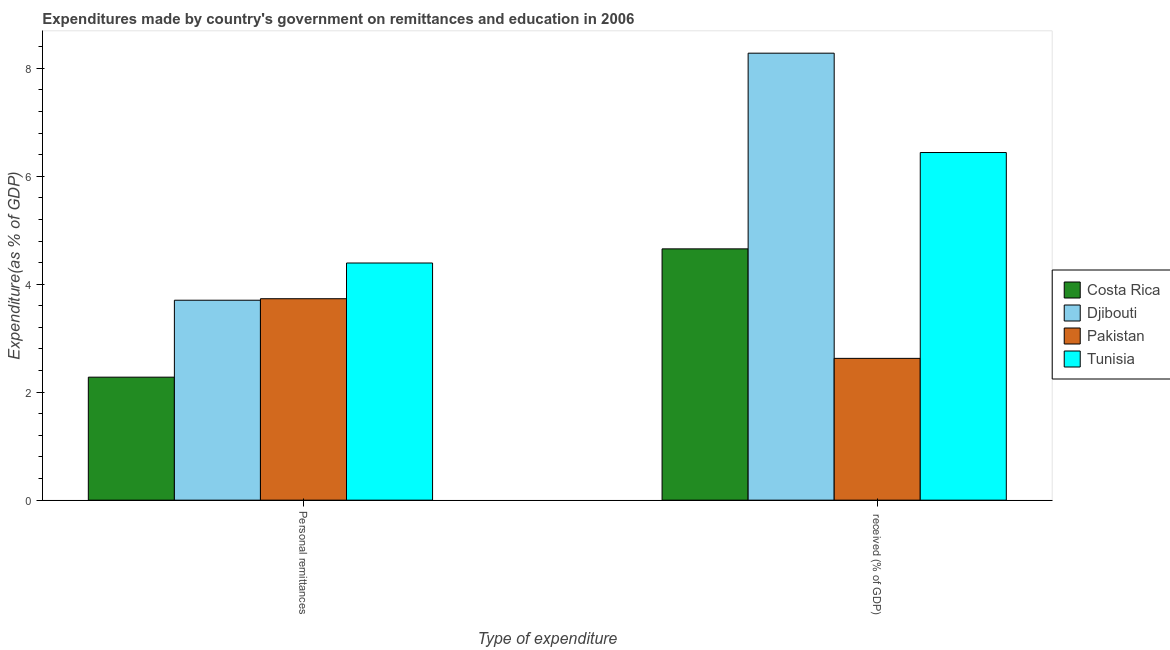How many different coloured bars are there?
Give a very brief answer. 4. What is the label of the 2nd group of bars from the left?
Your answer should be compact.  received (% of GDP). What is the expenditure in education in Costa Rica?
Provide a succinct answer. 4.65. Across all countries, what is the maximum expenditure in personal remittances?
Your answer should be compact. 4.39. Across all countries, what is the minimum expenditure in personal remittances?
Make the answer very short. 2.28. In which country was the expenditure in personal remittances maximum?
Provide a short and direct response. Tunisia. What is the total expenditure in education in the graph?
Provide a succinct answer. 22. What is the difference between the expenditure in personal remittances in Tunisia and that in Djibouti?
Offer a very short reply. 0.69. What is the difference between the expenditure in personal remittances in Djibouti and the expenditure in education in Costa Rica?
Ensure brevity in your answer.  -0.95. What is the average expenditure in personal remittances per country?
Your answer should be compact. 3.53. What is the difference between the expenditure in personal remittances and expenditure in education in Tunisia?
Keep it short and to the point. -2.05. In how many countries, is the expenditure in personal remittances greater than 2.4 %?
Keep it short and to the point. 3. What is the ratio of the expenditure in education in Tunisia to that in Djibouti?
Your response must be concise. 0.78. In how many countries, is the expenditure in personal remittances greater than the average expenditure in personal remittances taken over all countries?
Provide a succinct answer. 3. What does the 2nd bar from the left in  received (% of GDP) represents?
Provide a succinct answer. Djibouti. What does the 4th bar from the right in Personal remittances represents?
Offer a terse response. Costa Rica. Are all the bars in the graph horizontal?
Offer a terse response. No. How many countries are there in the graph?
Make the answer very short. 4. What is the difference between two consecutive major ticks on the Y-axis?
Your answer should be compact. 2. Are the values on the major ticks of Y-axis written in scientific E-notation?
Make the answer very short. No. Does the graph contain grids?
Make the answer very short. No. How are the legend labels stacked?
Give a very brief answer. Vertical. What is the title of the graph?
Ensure brevity in your answer.  Expenditures made by country's government on remittances and education in 2006. What is the label or title of the X-axis?
Your answer should be very brief. Type of expenditure. What is the label or title of the Y-axis?
Provide a short and direct response. Expenditure(as % of GDP). What is the Expenditure(as % of GDP) of Costa Rica in Personal remittances?
Provide a short and direct response. 2.28. What is the Expenditure(as % of GDP) in Djibouti in Personal remittances?
Provide a short and direct response. 3.7. What is the Expenditure(as % of GDP) of Pakistan in Personal remittances?
Your answer should be compact. 3.73. What is the Expenditure(as % of GDP) in Tunisia in Personal remittances?
Your answer should be very brief. 4.39. What is the Expenditure(as % of GDP) of Costa Rica in  received (% of GDP)?
Your answer should be compact. 4.65. What is the Expenditure(as % of GDP) of Djibouti in  received (% of GDP)?
Ensure brevity in your answer.  8.28. What is the Expenditure(as % of GDP) of Pakistan in  received (% of GDP)?
Make the answer very short. 2.63. What is the Expenditure(as % of GDP) in Tunisia in  received (% of GDP)?
Ensure brevity in your answer.  6.44. Across all Type of expenditure, what is the maximum Expenditure(as % of GDP) in Costa Rica?
Make the answer very short. 4.65. Across all Type of expenditure, what is the maximum Expenditure(as % of GDP) of Djibouti?
Keep it short and to the point. 8.28. Across all Type of expenditure, what is the maximum Expenditure(as % of GDP) in Pakistan?
Keep it short and to the point. 3.73. Across all Type of expenditure, what is the maximum Expenditure(as % of GDP) in Tunisia?
Your answer should be very brief. 6.44. Across all Type of expenditure, what is the minimum Expenditure(as % of GDP) in Costa Rica?
Give a very brief answer. 2.28. Across all Type of expenditure, what is the minimum Expenditure(as % of GDP) of Djibouti?
Your response must be concise. 3.7. Across all Type of expenditure, what is the minimum Expenditure(as % of GDP) in Pakistan?
Give a very brief answer. 2.63. Across all Type of expenditure, what is the minimum Expenditure(as % of GDP) of Tunisia?
Keep it short and to the point. 4.39. What is the total Expenditure(as % of GDP) of Costa Rica in the graph?
Make the answer very short. 6.93. What is the total Expenditure(as % of GDP) in Djibouti in the graph?
Keep it short and to the point. 11.98. What is the total Expenditure(as % of GDP) of Pakistan in the graph?
Your answer should be compact. 6.36. What is the total Expenditure(as % of GDP) of Tunisia in the graph?
Offer a very short reply. 10.83. What is the difference between the Expenditure(as % of GDP) of Costa Rica in Personal remittances and that in  received (% of GDP)?
Your answer should be very brief. -2.38. What is the difference between the Expenditure(as % of GDP) of Djibouti in Personal remittances and that in  received (% of GDP)?
Provide a short and direct response. -4.58. What is the difference between the Expenditure(as % of GDP) of Pakistan in Personal remittances and that in  received (% of GDP)?
Provide a succinct answer. 1.1. What is the difference between the Expenditure(as % of GDP) of Tunisia in Personal remittances and that in  received (% of GDP)?
Make the answer very short. -2.05. What is the difference between the Expenditure(as % of GDP) in Costa Rica in Personal remittances and the Expenditure(as % of GDP) in Djibouti in  received (% of GDP)?
Make the answer very short. -6. What is the difference between the Expenditure(as % of GDP) of Costa Rica in Personal remittances and the Expenditure(as % of GDP) of Pakistan in  received (% of GDP)?
Offer a terse response. -0.35. What is the difference between the Expenditure(as % of GDP) in Costa Rica in Personal remittances and the Expenditure(as % of GDP) in Tunisia in  received (% of GDP)?
Your response must be concise. -4.16. What is the difference between the Expenditure(as % of GDP) of Djibouti in Personal remittances and the Expenditure(as % of GDP) of Pakistan in  received (% of GDP)?
Your response must be concise. 1.08. What is the difference between the Expenditure(as % of GDP) of Djibouti in Personal remittances and the Expenditure(as % of GDP) of Tunisia in  received (% of GDP)?
Your response must be concise. -2.74. What is the difference between the Expenditure(as % of GDP) in Pakistan in Personal remittances and the Expenditure(as % of GDP) in Tunisia in  received (% of GDP)?
Provide a succinct answer. -2.71. What is the average Expenditure(as % of GDP) of Costa Rica per Type of expenditure?
Your answer should be compact. 3.47. What is the average Expenditure(as % of GDP) in Djibouti per Type of expenditure?
Provide a short and direct response. 5.99. What is the average Expenditure(as % of GDP) of Pakistan per Type of expenditure?
Your response must be concise. 3.18. What is the average Expenditure(as % of GDP) of Tunisia per Type of expenditure?
Your answer should be compact. 5.42. What is the difference between the Expenditure(as % of GDP) of Costa Rica and Expenditure(as % of GDP) of Djibouti in Personal remittances?
Give a very brief answer. -1.43. What is the difference between the Expenditure(as % of GDP) in Costa Rica and Expenditure(as % of GDP) in Pakistan in Personal remittances?
Your response must be concise. -1.45. What is the difference between the Expenditure(as % of GDP) in Costa Rica and Expenditure(as % of GDP) in Tunisia in Personal remittances?
Ensure brevity in your answer.  -2.11. What is the difference between the Expenditure(as % of GDP) in Djibouti and Expenditure(as % of GDP) in Pakistan in Personal remittances?
Keep it short and to the point. -0.03. What is the difference between the Expenditure(as % of GDP) in Djibouti and Expenditure(as % of GDP) in Tunisia in Personal remittances?
Ensure brevity in your answer.  -0.69. What is the difference between the Expenditure(as % of GDP) in Pakistan and Expenditure(as % of GDP) in Tunisia in Personal remittances?
Your response must be concise. -0.66. What is the difference between the Expenditure(as % of GDP) in Costa Rica and Expenditure(as % of GDP) in Djibouti in  received (% of GDP)?
Provide a succinct answer. -3.62. What is the difference between the Expenditure(as % of GDP) in Costa Rica and Expenditure(as % of GDP) in Pakistan in  received (% of GDP)?
Your response must be concise. 2.03. What is the difference between the Expenditure(as % of GDP) of Costa Rica and Expenditure(as % of GDP) of Tunisia in  received (% of GDP)?
Keep it short and to the point. -1.78. What is the difference between the Expenditure(as % of GDP) in Djibouti and Expenditure(as % of GDP) in Pakistan in  received (% of GDP)?
Provide a short and direct response. 5.65. What is the difference between the Expenditure(as % of GDP) of Djibouti and Expenditure(as % of GDP) of Tunisia in  received (% of GDP)?
Your answer should be very brief. 1.84. What is the difference between the Expenditure(as % of GDP) of Pakistan and Expenditure(as % of GDP) of Tunisia in  received (% of GDP)?
Ensure brevity in your answer.  -3.81. What is the ratio of the Expenditure(as % of GDP) in Costa Rica in Personal remittances to that in  received (% of GDP)?
Your response must be concise. 0.49. What is the ratio of the Expenditure(as % of GDP) in Djibouti in Personal remittances to that in  received (% of GDP)?
Offer a terse response. 0.45. What is the ratio of the Expenditure(as % of GDP) in Pakistan in Personal remittances to that in  received (% of GDP)?
Provide a short and direct response. 1.42. What is the ratio of the Expenditure(as % of GDP) of Tunisia in Personal remittances to that in  received (% of GDP)?
Provide a succinct answer. 0.68. What is the difference between the highest and the second highest Expenditure(as % of GDP) in Costa Rica?
Ensure brevity in your answer.  2.38. What is the difference between the highest and the second highest Expenditure(as % of GDP) of Djibouti?
Your response must be concise. 4.58. What is the difference between the highest and the second highest Expenditure(as % of GDP) of Pakistan?
Give a very brief answer. 1.1. What is the difference between the highest and the second highest Expenditure(as % of GDP) in Tunisia?
Make the answer very short. 2.05. What is the difference between the highest and the lowest Expenditure(as % of GDP) of Costa Rica?
Provide a succinct answer. 2.38. What is the difference between the highest and the lowest Expenditure(as % of GDP) in Djibouti?
Offer a very short reply. 4.58. What is the difference between the highest and the lowest Expenditure(as % of GDP) of Pakistan?
Your answer should be compact. 1.1. What is the difference between the highest and the lowest Expenditure(as % of GDP) in Tunisia?
Your answer should be very brief. 2.05. 